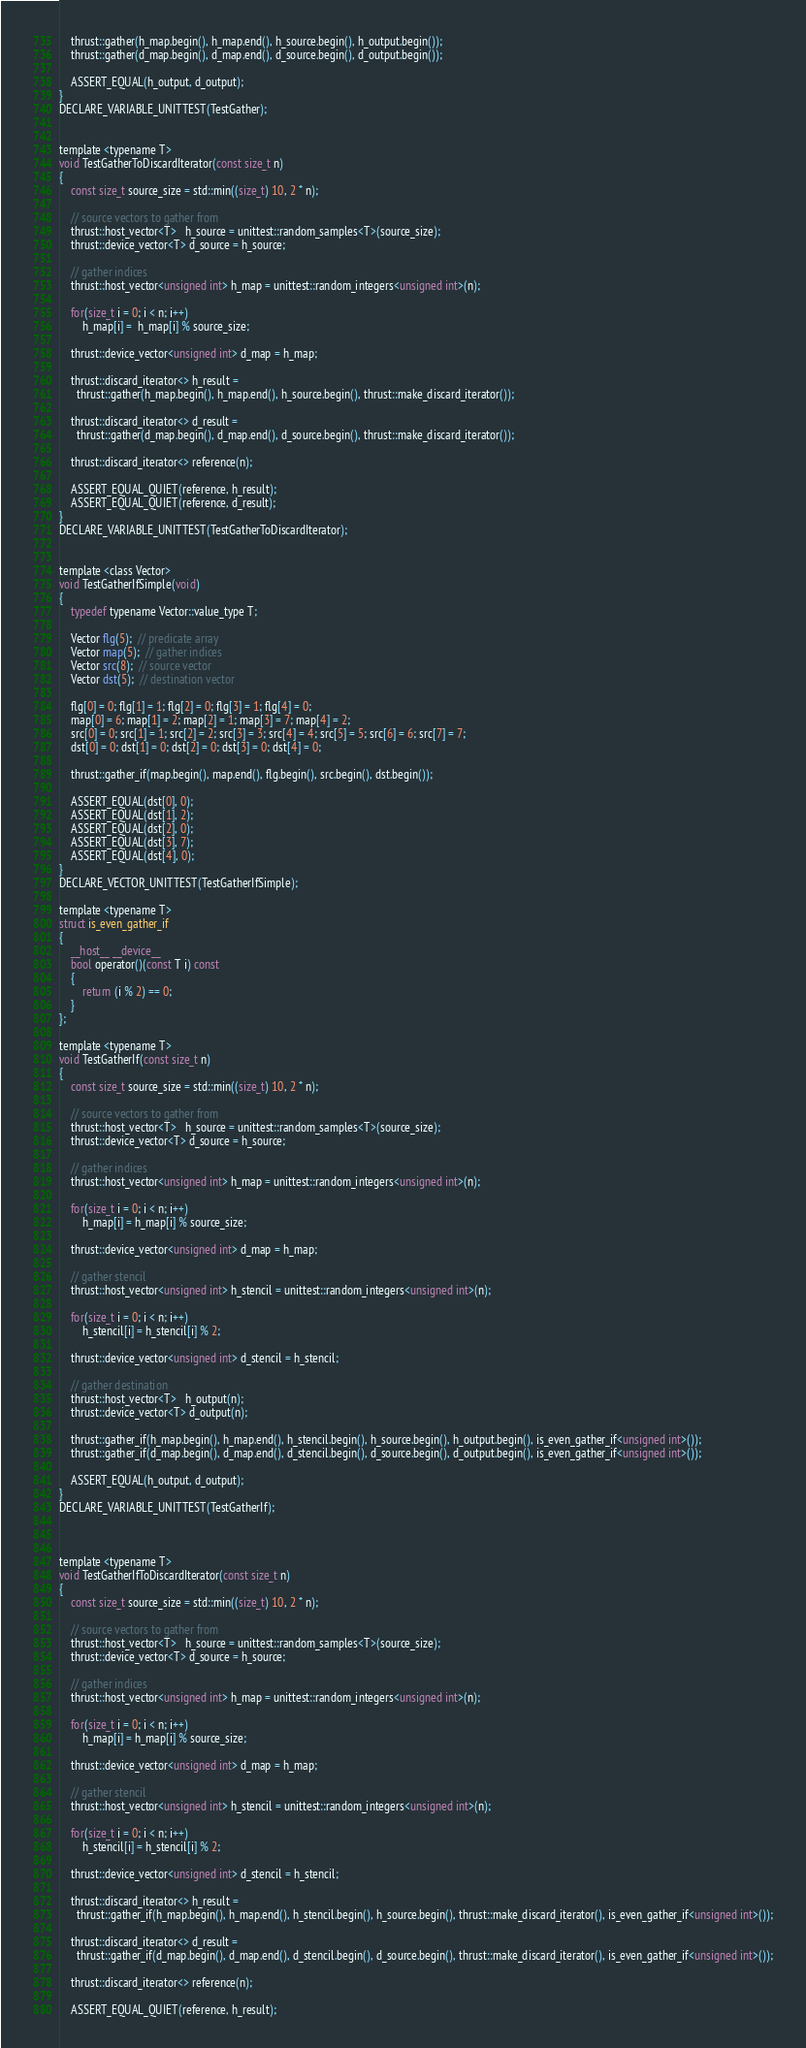<code> <loc_0><loc_0><loc_500><loc_500><_Cuda_>
    thrust::gather(h_map.begin(), h_map.end(), h_source.begin(), h_output.begin());
    thrust::gather(d_map.begin(), d_map.end(), d_source.begin(), d_output.begin());

    ASSERT_EQUAL(h_output, d_output);
}
DECLARE_VARIABLE_UNITTEST(TestGather);


template <typename T>
void TestGatherToDiscardIterator(const size_t n)
{
    const size_t source_size = std::min((size_t) 10, 2 * n);

    // source vectors to gather from
    thrust::host_vector<T>   h_source = unittest::random_samples<T>(source_size);
    thrust::device_vector<T> d_source = h_source;
  
    // gather indices
    thrust::host_vector<unsigned int> h_map = unittest::random_integers<unsigned int>(n);

    for(size_t i = 0; i < n; i++)
        h_map[i] =  h_map[i] % source_size;
    
    thrust::device_vector<unsigned int> d_map = h_map;

    thrust::discard_iterator<> h_result = 
      thrust::gather(h_map.begin(), h_map.end(), h_source.begin(), thrust::make_discard_iterator());

    thrust::discard_iterator<> d_result =
      thrust::gather(d_map.begin(), d_map.end(), d_source.begin(), thrust::make_discard_iterator());

    thrust::discard_iterator<> reference(n);

    ASSERT_EQUAL_QUIET(reference, h_result);
    ASSERT_EQUAL_QUIET(reference, d_result);
}
DECLARE_VARIABLE_UNITTEST(TestGatherToDiscardIterator);


template <class Vector>
void TestGatherIfSimple(void)
{
    typedef typename Vector::value_type T;

    Vector flg(5);  // predicate array
    Vector map(5);  // gather indices
    Vector src(8);  // source vector
    Vector dst(5);  // destination vector

    flg[0] = 0; flg[1] = 1; flg[2] = 0; flg[3] = 1; flg[4] = 0;
    map[0] = 6; map[1] = 2; map[2] = 1; map[3] = 7; map[4] = 2;
    src[0] = 0; src[1] = 1; src[2] = 2; src[3] = 3; src[4] = 4; src[5] = 5; src[6] = 6; src[7] = 7;
    dst[0] = 0; dst[1] = 0; dst[2] = 0; dst[3] = 0; dst[4] = 0;

    thrust::gather_if(map.begin(), map.end(), flg.begin(), src.begin(), dst.begin());

    ASSERT_EQUAL(dst[0], 0);
    ASSERT_EQUAL(dst[1], 2);
    ASSERT_EQUAL(dst[2], 0);
    ASSERT_EQUAL(dst[3], 7);
    ASSERT_EQUAL(dst[4], 0);
}
DECLARE_VECTOR_UNITTEST(TestGatherIfSimple);

template <typename T>
struct is_even_gather_if
{
    __host__ __device__
    bool operator()(const T i) const
    { 
        return (i % 2) == 0;
    }
};

template <typename T>
void TestGatherIf(const size_t n)
{
    const size_t source_size = std::min((size_t) 10, 2 * n);

    // source vectors to gather from
    thrust::host_vector<T>   h_source = unittest::random_samples<T>(source_size);
    thrust::device_vector<T> d_source = h_source;
  
    // gather indices
    thrust::host_vector<unsigned int> h_map = unittest::random_integers<unsigned int>(n);

    for(size_t i = 0; i < n; i++)
        h_map[i] = h_map[i] % source_size;
    
    thrust::device_vector<unsigned int> d_map = h_map;
    
    // gather stencil
    thrust::host_vector<unsigned int> h_stencil = unittest::random_integers<unsigned int>(n);

    for(size_t i = 0; i < n; i++)
        h_stencil[i] = h_stencil[i] % 2;
    
    thrust::device_vector<unsigned int> d_stencil = h_stencil;

    // gather destination
    thrust::host_vector<T>   h_output(n);
    thrust::device_vector<T> d_output(n);

    thrust::gather_if(h_map.begin(), h_map.end(), h_stencil.begin(), h_source.begin(), h_output.begin(), is_even_gather_if<unsigned int>());
    thrust::gather_if(d_map.begin(), d_map.end(), d_stencil.begin(), d_source.begin(), d_output.begin(), is_even_gather_if<unsigned int>());

    ASSERT_EQUAL(h_output, d_output);
}
DECLARE_VARIABLE_UNITTEST(TestGatherIf);



template <typename T>
void TestGatherIfToDiscardIterator(const size_t n)
{
    const size_t source_size = std::min((size_t) 10, 2 * n);

    // source vectors to gather from
    thrust::host_vector<T>   h_source = unittest::random_samples<T>(source_size);
    thrust::device_vector<T> d_source = h_source;
  
    // gather indices
    thrust::host_vector<unsigned int> h_map = unittest::random_integers<unsigned int>(n);

    for(size_t i = 0; i < n; i++)
        h_map[i] = h_map[i] % source_size;
    
    thrust::device_vector<unsigned int> d_map = h_map;
    
    // gather stencil
    thrust::host_vector<unsigned int> h_stencil = unittest::random_integers<unsigned int>(n);

    for(size_t i = 0; i < n; i++)
        h_stencil[i] = h_stencil[i] % 2;
    
    thrust::device_vector<unsigned int> d_stencil = h_stencil;

    thrust::discard_iterator<> h_result =
      thrust::gather_if(h_map.begin(), h_map.end(), h_stencil.begin(), h_source.begin(), thrust::make_discard_iterator(), is_even_gather_if<unsigned int>());

    thrust::discard_iterator<> d_result =
      thrust::gather_if(d_map.begin(), d_map.end(), d_stencil.begin(), d_source.begin(), thrust::make_discard_iterator(), is_even_gather_if<unsigned int>());

    thrust::discard_iterator<> reference(n);

    ASSERT_EQUAL_QUIET(reference, h_result);</code> 